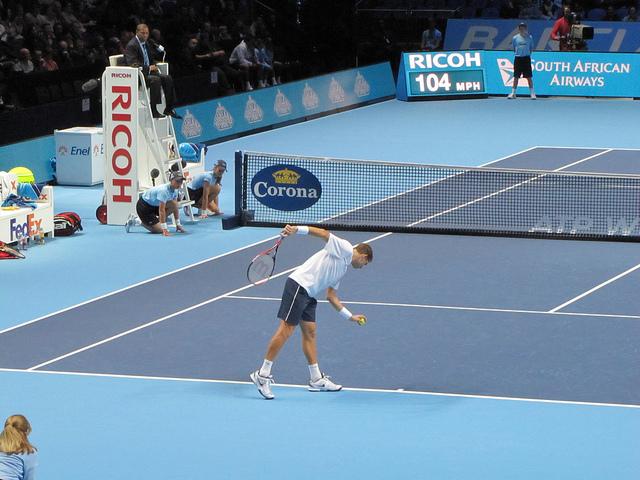Who is one of the sponsors of the game?
Give a very brief answer. Corona. What color is the court?
Write a very short answer. Blue. What is the man pictured getting ready to do?
Keep it brief. Serve. 